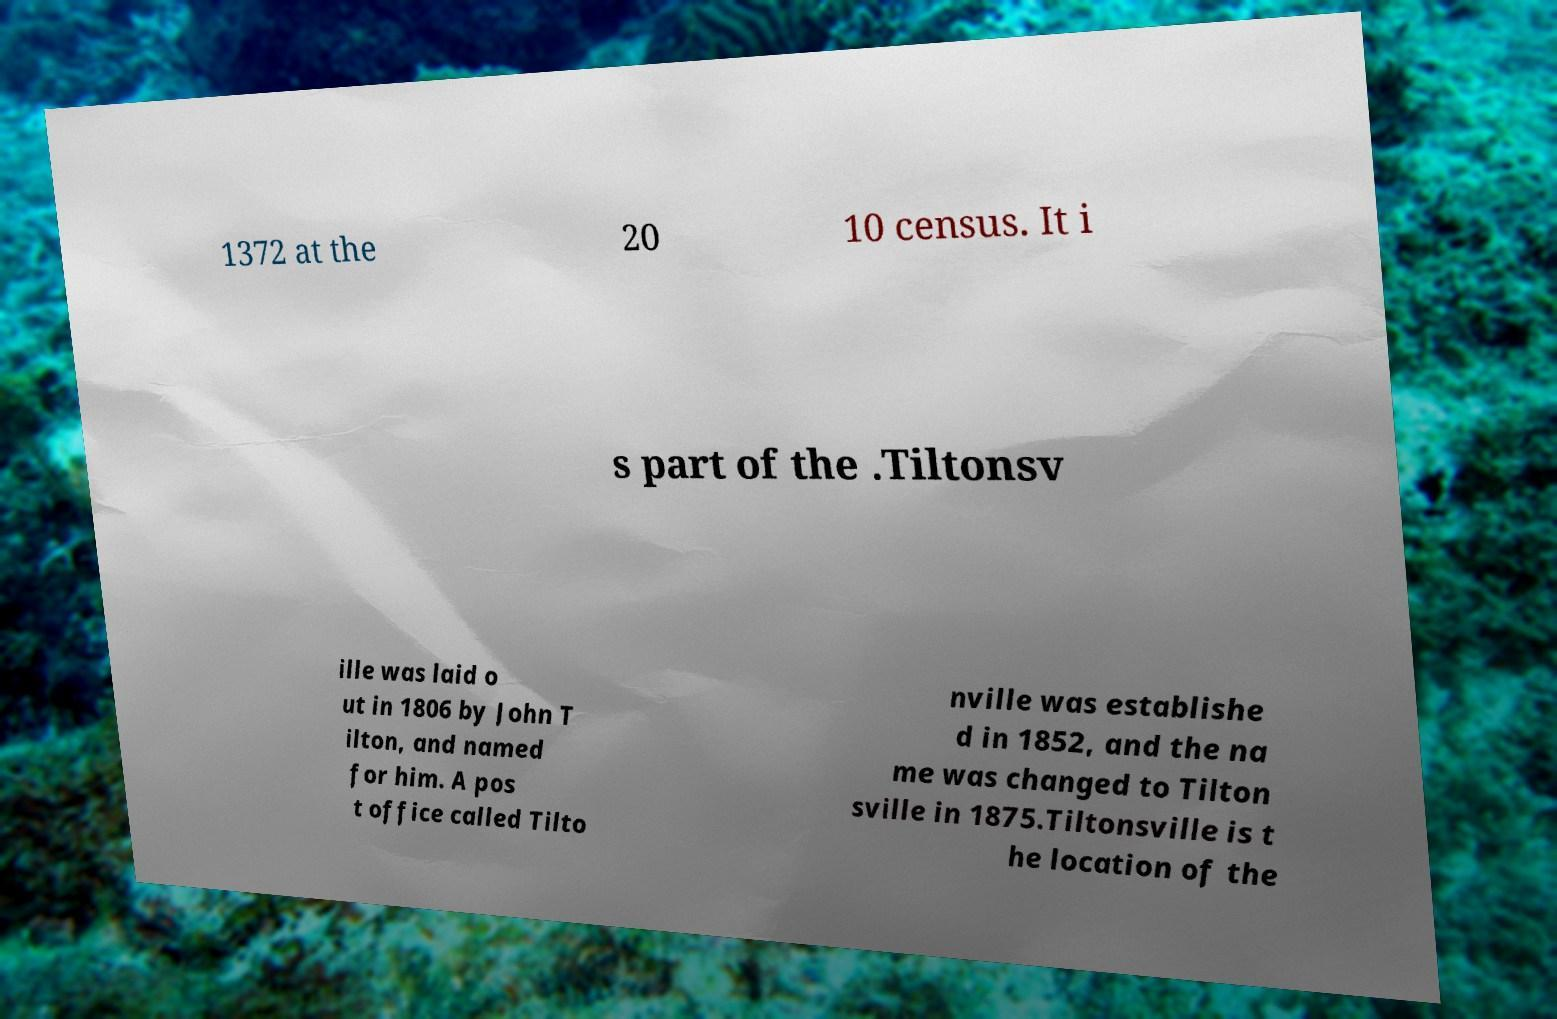I need the written content from this picture converted into text. Can you do that? 1372 at the 20 10 census. It i s part of the .Tiltonsv ille was laid o ut in 1806 by John T ilton, and named for him. A pos t office called Tilto nville was establishe d in 1852, and the na me was changed to Tilton sville in 1875.Tiltonsville is t he location of the 